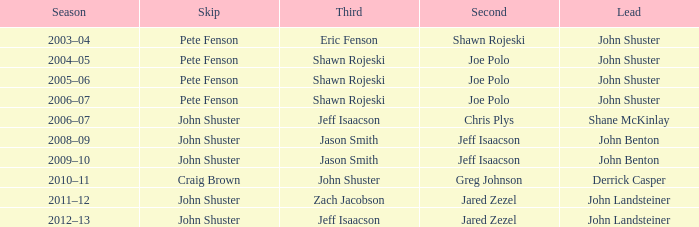Who was the lead with John Shuster as skip, Chris Plys in second, and Jeff Isaacson in third? Shane McKinlay. 